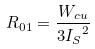<formula> <loc_0><loc_0><loc_500><loc_500>R _ { 0 1 } = \frac { W _ { c u } } { 3 { I _ { S } } ^ { 2 } }</formula> 